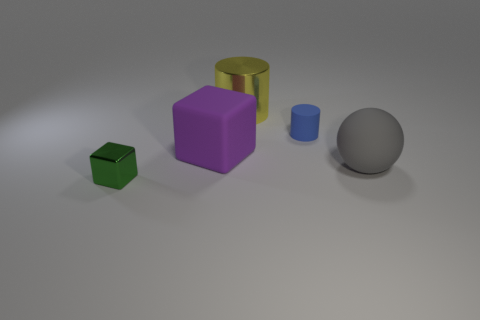Do the shiny block and the metallic object behind the tiny shiny thing have the same color?
Ensure brevity in your answer.  No. What is the shape of the large purple object that is made of the same material as the gray object?
Give a very brief answer. Cube. How many balls are there?
Offer a very short reply. 1. What number of things are tiny objects that are behind the large gray sphere or big green metal cylinders?
Your response must be concise. 1. Is the color of the matte thing that is on the left side of the tiny matte cylinder the same as the tiny matte object?
Your response must be concise. No. What number of other objects are the same color as the large cube?
Keep it short and to the point. 0. How many big objects are gray rubber objects or shiny cylinders?
Provide a succinct answer. 2. Are there more tiny green metallic things than small brown metallic cylinders?
Keep it short and to the point. Yes. Is the big purple cube made of the same material as the ball?
Offer a very short reply. Yes. Is there any other thing that is made of the same material as the yellow thing?
Provide a short and direct response. Yes. 